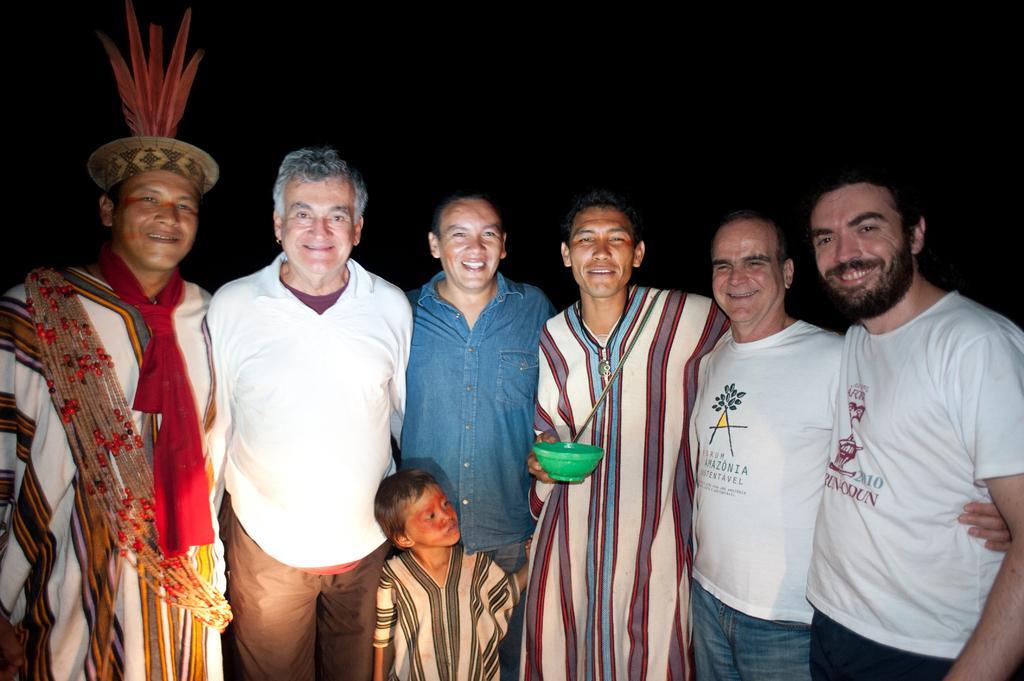Could you give a brief overview of what you see in this image? As we can see in the image in the front there are group of people standing. The person over here is holding a green color bowl and the background is dark. 